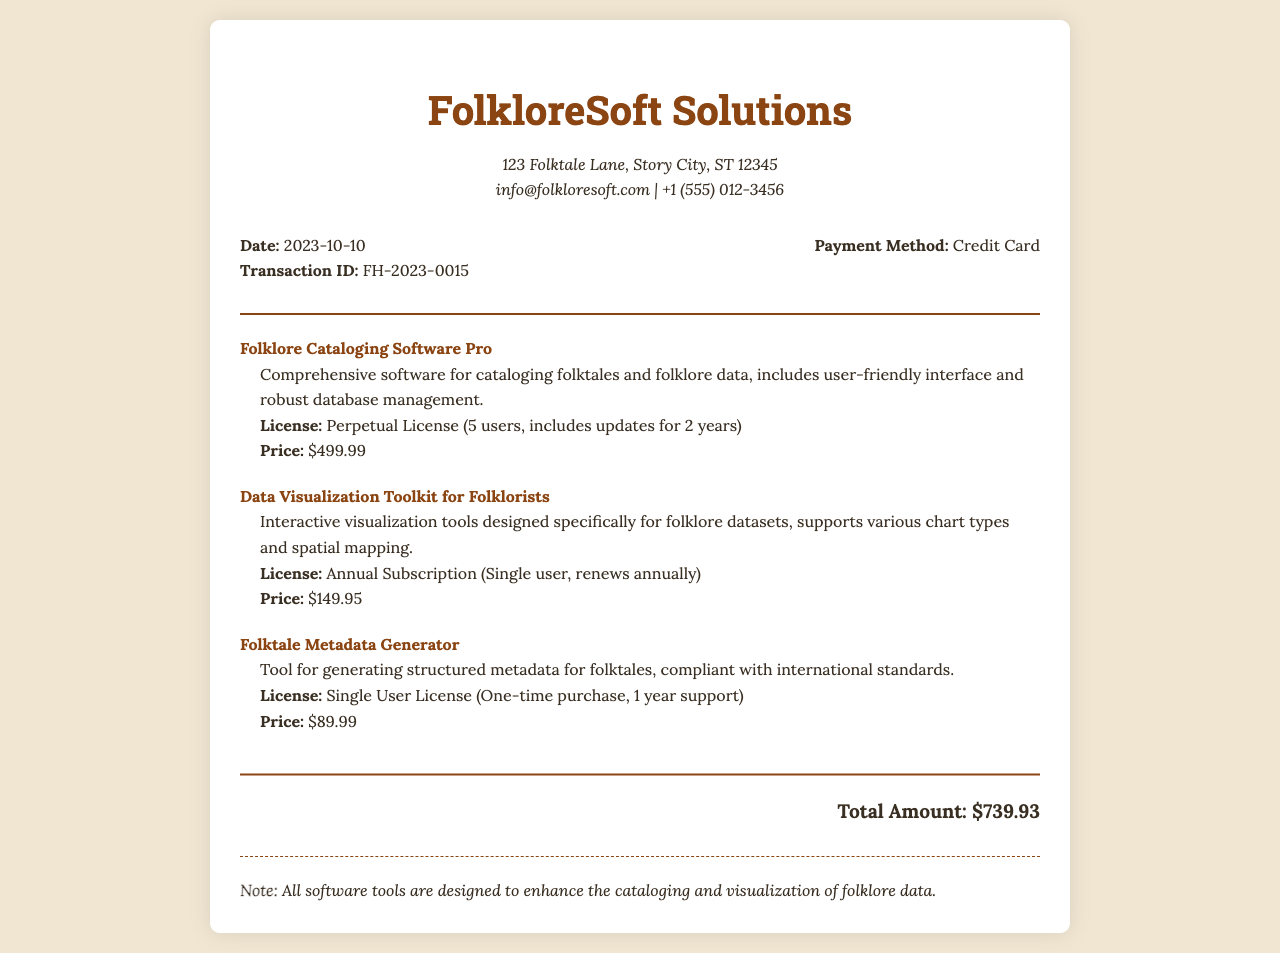what is the date of the transaction? The date of the transaction is listed in the receipt details section.
Answer: 2023-10-10 what is the transaction ID? The transaction ID is provided in the receipt details section.
Answer: FH-2023-0015 who is the vendor? The vendor's name is displayed prominently at the top of the receipt.
Answer: FolkloreSoft Solutions what is the price of the Folklore Cataloging Software Pro? The price is specifically mentioned in the item details section for that software.
Answer: $499.99 what type of license is offered for the Data Visualization Toolkit for Folklorists? The license type is detailed in the item description for that software.
Answer: Annual Subscription (Single user, renews annually) how many users does the Folklore Cataloging Software Pro license cover? The number of users is explicitly stated in the item details for the software.
Answer: 5 users what is the total amount of the receipt? The total amount is calculated and displayed at the bottom of the receipt.
Answer: $739.93 what is the support duration for the Folktale Metadata Generator license? The support duration is mentioned in the item details for that tool.
Answer: 1 year support what payment method was used? The payment method is conveyed in the receipt details section.
Answer: Credit Card 